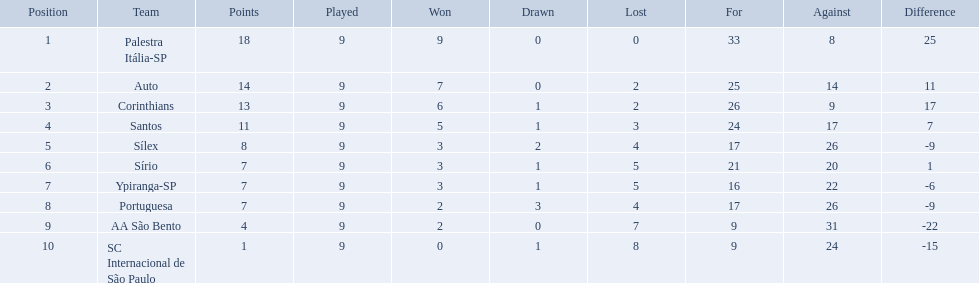What teams played in 1926? Palestra Itália-SP, Auto, Corinthians, Santos, Sílex, Sírio, Ypiranga-SP, Portuguesa, AA São Bento, SC Internacional de São Paulo. Did any team lose zero games? Palestra Itália-SP. How many games did each team play? 9, 9, 9, 9, 9, 9, 9, 9, 9, 9. Did any team score 13 points in the total games they played? 13. What is the name of that team? Corinthians. How many points were scored by the teams? 18, 14, 13, 11, 8, 7, 7, 7, 4, 1. What team scored 13 points? Corinthians. What were the top three amounts of games won for 1926 in brazilian football season? 9, 7, 6. What were the top amount of games won for 1926 in brazilian football season? 9. What team won the top amount of games Palestra Itália-SP. Which squads participated in brazilian soccer in 1926? Palestra Itália-SP, Auto, Corinthians, Santos, Sílex, Sírio, Ypiranga-SP, Portuguesa, AA São Bento, SC Internacional de São Paulo. Among those squads, which one achieved 13 points? Corinthians. I'm looking to parse the entire table for insights. Could you assist me with that? {'header': ['Position', 'Team', 'Points', 'Played', 'Won', 'Drawn', 'Lost', 'For', 'Against', 'Difference'], 'rows': [['1', 'Palestra Itália-SP', '18', '9', '9', '0', '0', '33', '8', '25'], ['2', 'Auto', '14', '9', '7', '0', '2', '25', '14', '11'], ['3', 'Corinthians', '13', '9', '6', '1', '2', '26', '9', '17'], ['4', 'Santos', '11', '9', '5', '1', '3', '24', '17', '7'], ['5', 'Sílex', '8', '9', '3', '2', '4', '17', '26', '-9'], ['6', 'Sírio', '7', '9', '3', '1', '5', '21', '20', '1'], ['7', 'Ypiranga-SP', '7', '9', '3', '1', '5', '16', '22', '-6'], ['8', 'Portuguesa', '7', '9', '2', '3', '4', '17', '26', '-9'], ['9', 'AA São Bento', '4', '9', '2', '0', '7', '9', '31', '-22'], ['10', 'SC Internacional de São Paulo', '1', '9', '0', '1', '8', '9', '24', '-15']]} In 1926, which brazilian soccer teams had no ties? Palestra Itália-SP, Auto, AA São Bento. Among those teams, which two had the least losses? Palestra Itália-SP, Auto. And which of those two with the least losses and no ties had the highest goal difference? Palestra Itália-SP. What is the total number of points accumulated by the teams? 18, 14, 13, 11, 8, 7, 7, 7, 4, 1. Which team managed to score 13 points? Corinthians. What are all the team names? Palestra Itália-SP, Auto, Corinthians, Santos, Sílex, Sírio, Ypiranga-SP, Portuguesa, AA São Bento, SC Internacional de São Paulo. How many losses did each team have? 0, 2, 2, 3, 4, 5, 5, 4, 7, 8. And which team had zero losses? Palestra Itália-SP. What were all the clubs that played in the 1926 brazilian football? Palestra Itália-SP, Auto, Corinthians, Santos, Sílex, Sírio, Ypiranga-SP, Portuguesa, AA São Bento, SC Internacional de São Paulo. Out of them, which had no losses in games? Palestra Itália-SP. What is the complete list of teams? Palestra Itália-SP, Auto, Corinthians, Santos, Sílex, Sírio, Ypiranga-SP, Portuguesa, AA São Bento, SC Internacional de São Paulo. How many losses did each team experience? 0, 2, 2, 3, 4, 5, 5, 4, 7, 8. And, is there a team that has never experienced a loss? Palestra Itália-SP. Can you provide a list of all the teams? Palestra Itália-SP, Auto, Corinthians, Santos, Sílex, Sírio, Ypiranga-SP, Portuguesa, AA São Bento, SC Internacional de São Paulo. How many losses did they each have? 0, 2, 2, 3, 4, 5, 5, 4, 7, 8. Also, which team has never been defeated? Palestra Itália-SP. What was the total number of games played by each team? 9, 9, 9, 9, 9, 9, 9, 9, 9, 9. Was there a team that managed to score 13 points in all their games? 13. If so, what is the team's name? Corinthians. For each team, how many games did they participate in? 9, 9, 9, 9, 9, 9, 9, 9, 9, 9. Did any of the teams achieve a total score of 13 points in their games? 13. Can you provide the name of that team? Corinthians. 